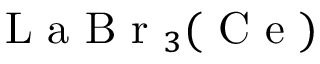<formula> <loc_0><loc_0><loc_500><loc_500>L a B r _ { 3 } ( C e )</formula> 